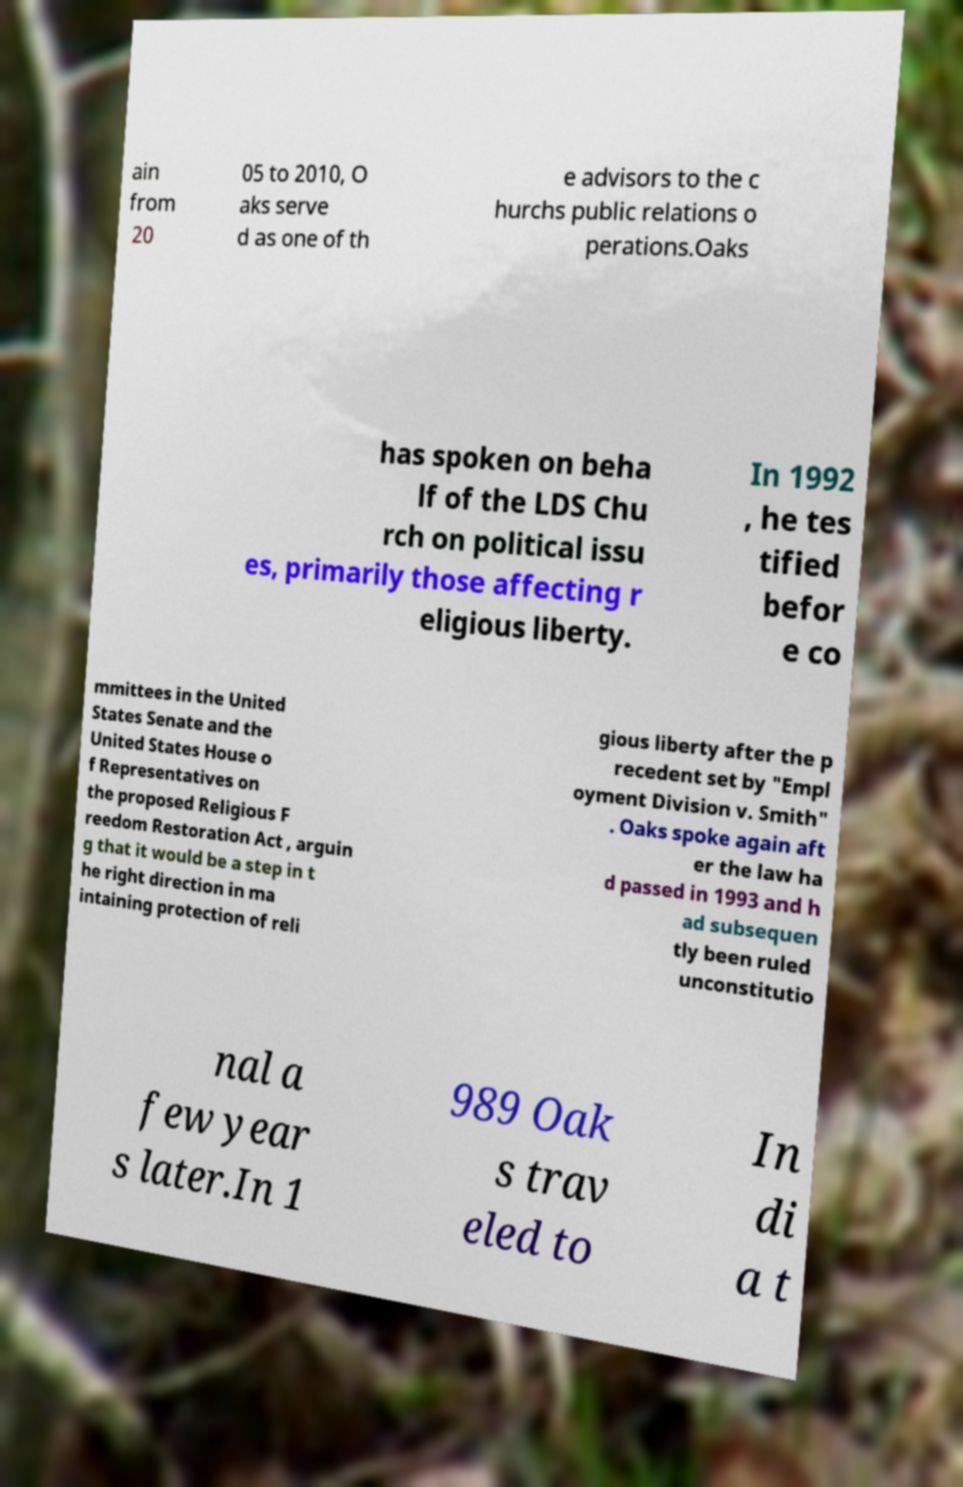Please identify and transcribe the text found in this image. ain from 20 05 to 2010, O aks serve d as one of th e advisors to the c hurchs public relations o perations.Oaks has spoken on beha lf of the LDS Chu rch on political issu es, primarily those affecting r eligious liberty. In 1992 , he tes tified befor e co mmittees in the United States Senate and the United States House o f Representatives on the proposed Religious F reedom Restoration Act , arguin g that it would be a step in t he right direction in ma intaining protection of reli gious liberty after the p recedent set by "Empl oyment Division v. Smith" . Oaks spoke again aft er the law ha d passed in 1993 and h ad subsequen tly been ruled unconstitutio nal a few year s later.In 1 989 Oak s trav eled to In di a t 